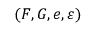Convert formula to latex. <formula><loc_0><loc_0><loc_500><loc_500>( F , G , e , \varepsilon )</formula> 